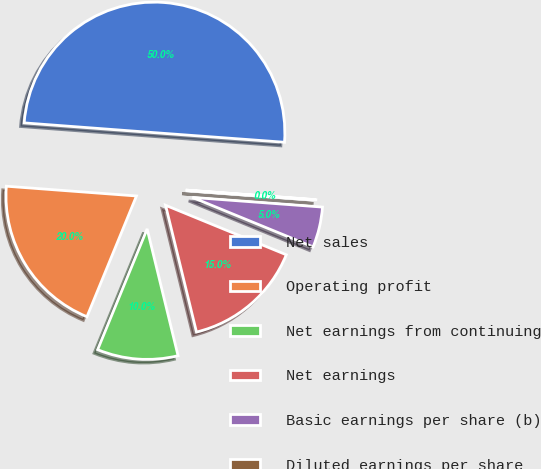Convert chart to OTSL. <chart><loc_0><loc_0><loc_500><loc_500><pie_chart><fcel>Net sales<fcel>Operating profit<fcel>Net earnings from continuing<fcel>Net earnings<fcel>Basic earnings per share (b)<fcel>Diluted earnings per share<nl><fcel>49.98%<fcel>20.0%<fcel>10.0%<fcel>15.0%<fcel>5.01%<fcel>0.01%<nl></chart> 